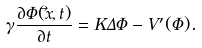Convert formula to latex. <formula><loc_0><loc_0><loc_500><loc_500>\gamma \frac { \partial \Phi ( \vec { x } , t ) } { \partial t } = K \Delta \Phi - V ^ { \prime } ( \Phi ) .</formula> 